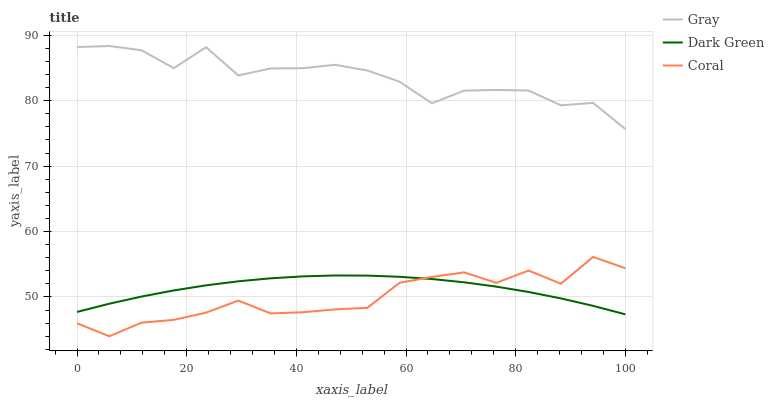Does Coral have the minimum area under the curve?
Answer yes or no. Yes. Does Gray have the maximum area under the curve?
Answer yes or no. Yes. Does Dark Green have the minimum area under the curve?
Answer yes or no. No. Does Dark Green have the maximum area under the curve?
Answer yes or no. No. Is Dark Green the smoothest?
Answer yes or no. Yes. Is Gray the roughest?
Answer yes or no. Yes. Is Coral the smoothest?
Answer yes or no. No. Is Coral the roughest?
Answer yes or no. No. Does Dark Green have the lowest value?
Answer yes or no. No. Does Coral have the highest value?
Answer yes or no. No. Is Dark Green less than Gray?
Answer yes or no. Yes. Is Gray greater than Dark Green?
Answer yes or no. Yes. Does Dark Green intersect Gray?
Answer yes or no. No. 